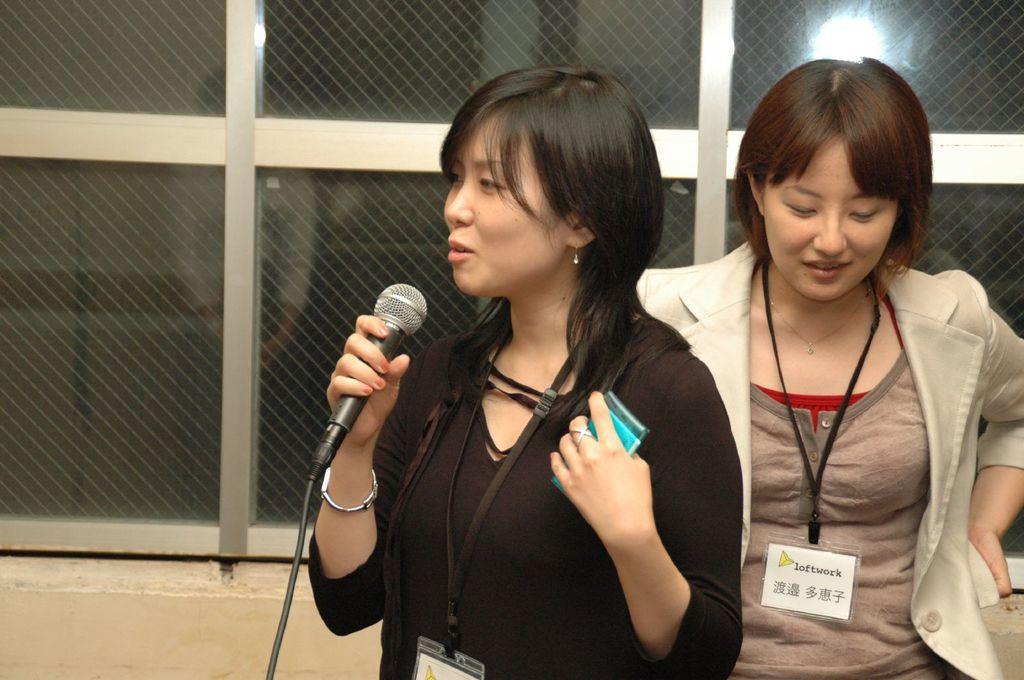Could you give a brief overview of what you see in this image? In this image there are two women standing. In front the woman is holding a mic. 